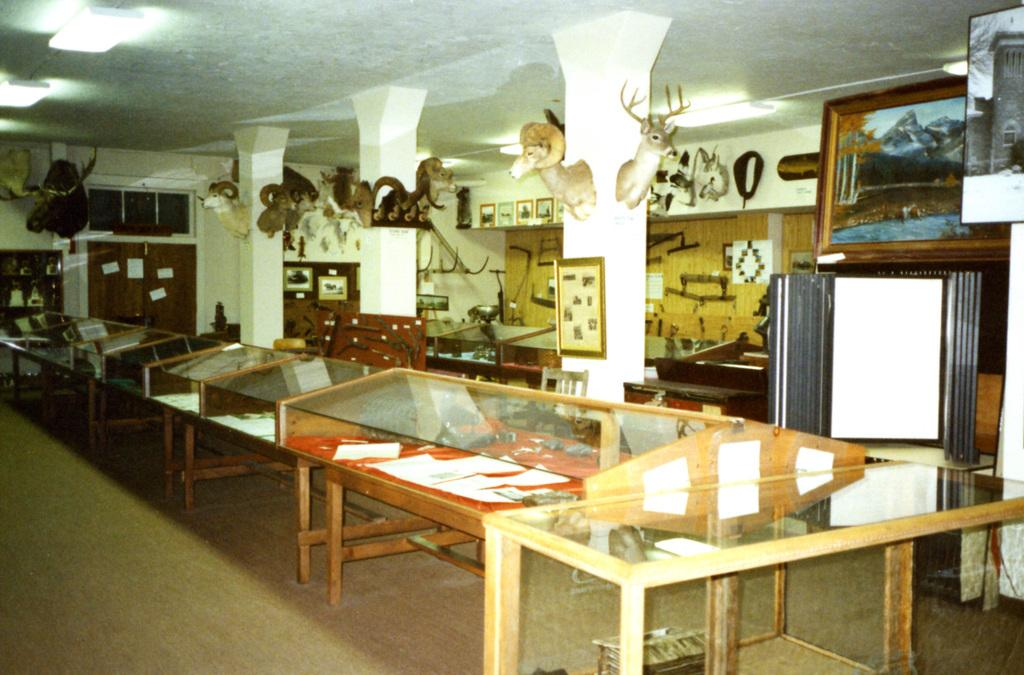What type of furniture is present in the image? There are many tables in the image. What can be seen on the wall in the image? There are photo frames on the wall in the image. What type of decorative objects are on pillars in the image? There are statues on pillars in the image. What type of bushes can be seen growing around the tables in the image? There are no bushes present in the image. Where is the sink located in the image? There is no sink present in the image. 